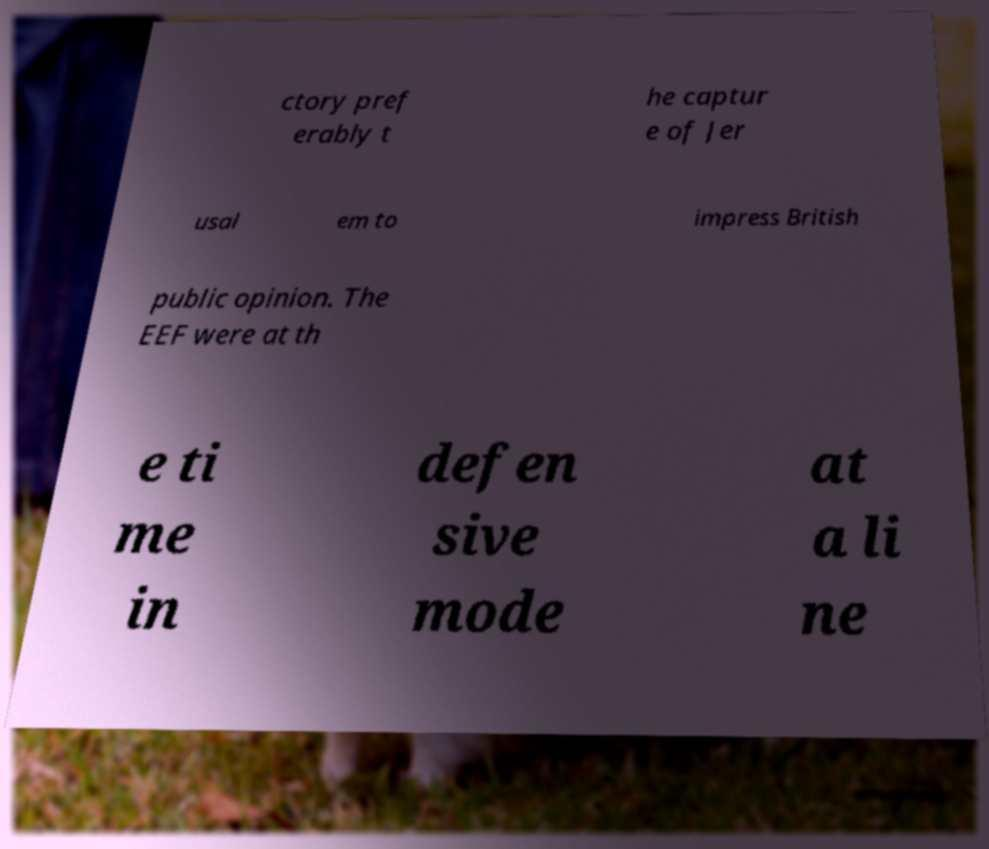Please identify and transcribe the text found in this image. ctory pref erably t he captur e of Jer usal em to impress British public opinion. The EEF were at th e ti me in defen sive mode at a li ne 